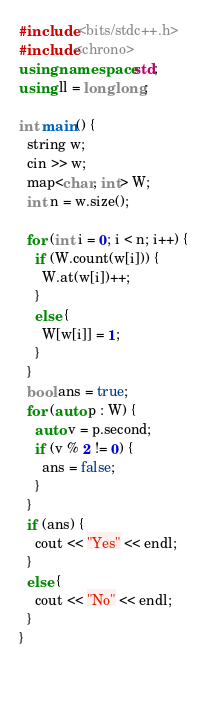<code> <loc_0><loc_0><loc_500><loc_500><_C++_>#include <bits/stdc++.h>
#include<chrono>
using namespace std;
using ll = long long;

int main() {
  string w;
  cin >> w;
  map<char, int> W;
  int n = w.size();
  
  for (int i = 0; i < n; i++) {
    if (W.count(w[i])) {
      W.at(w[i])++;
    }
    else {
      W[w[i]] = 1;
    }
  }
  bool ans = true;
  for (auto p : W) {
    auto v = p.second;
    if (v % 2 != 0) {
      ans = false;
    }
  }
  if (ans) {
    cout << "Yes" << endl;
  }
  else {
    cout << "No" << endl;
  }
}

    </code> 